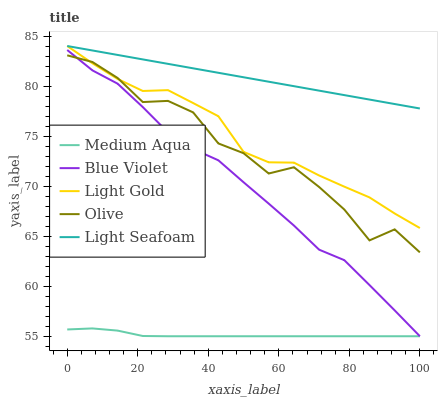Does Medium Aqua have the minimum area under the curve?
Answer yes or no. Yes. Does Light Seafoam have the maximum area under the curve?
Answer yes or no. Yes. Does Light Gold have the minimum area under the curve?
Answer yes or no. No. Does Light Gold have the maximum area under the curve?
Answer yes or no. No. Is Light Seafoam the smoothest?
Answer yes or no. Yes. Is Olive the roughest?
Answer yes or no. Yes. Is Light Gold the smoothest?
Answer yes or no. No. Is Light Gold the roughest?
Answer yes or no. No. Does Medium Aqua have the lowest value?
Answer yes or no. Yes. Does Light Gold have the lowest value?
Answer yes or no. No. Does Light Seafoam have the highest value?
Answer yes or no. Yes. Does Medium Aqua have the highest value?
Answer yes or no. No. Is Medium Aqua less than Light Seafoam?
Answer yes or no. Yes. Is Light Seafoam greater than Blue Violet?
Answer yes or no. Yes. Does Olive intersect Light Gold?
Answer yes or no. Yes. Is Olive less than Light Gold?
Answer yes or no. No. Is Olive greater than Light Gold?
Answer yes or no. No. Does Medium Aqua intersect Light Seafoam?
Answer yes or no. No. 